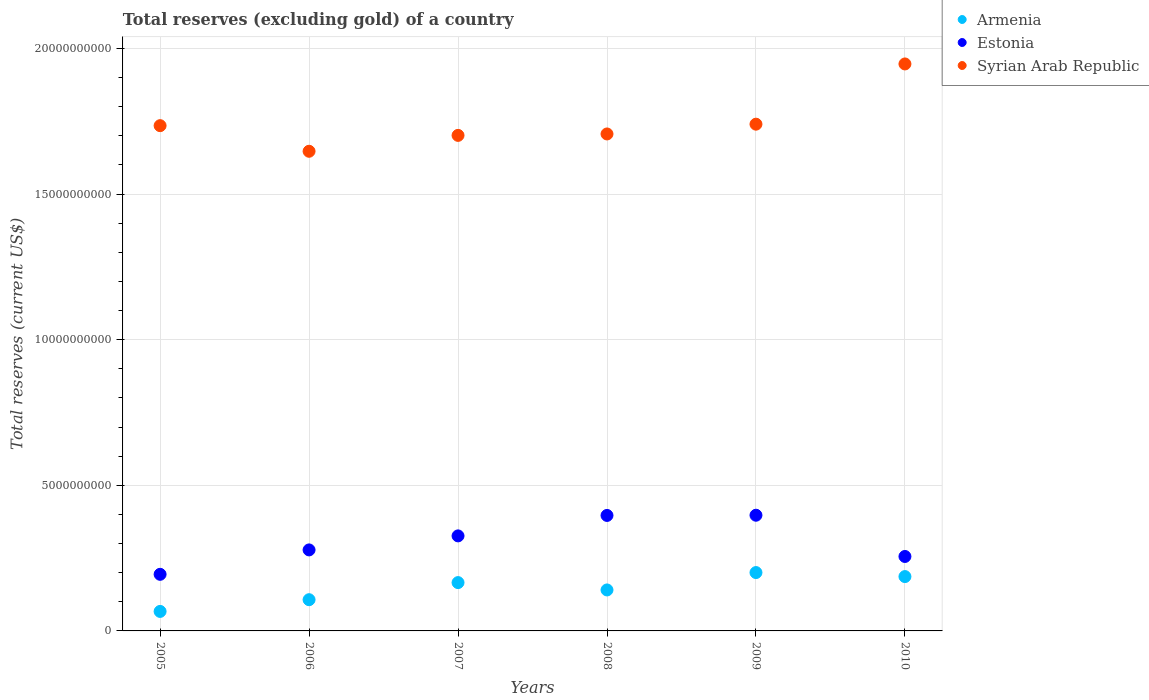How many different coloured dotlines are there?
Offer a very short reply. 3. Is the number of dotlines equal to the number of legend labels?
Offer a terse response. Yes. What is the total reserves (excluding gold) in Estonia in 2009?
Your answer should be compact. 3.97e+09. Across all years, what is the maximum total reserves (excluding gold) in Syrian Arab Republic?
Offer a terse response. 1.95e+1. Across all years, what is the minimum total reserves (excluding gold) in Syrian Arab Republic?
Offer a terse response. 1.65e+1. What is the total total reserves (excluding gold) in Estonia in the graph?
Make the answer very short. 1.85e+1. What is the difference between the total reserves (excluding gold) in Armenia in 2005 and that in 2006?
Ensure brevity in your answer.  -4.02e+08. What is the difference between the total reserves (excluding gold) in Estonia in 2005 and the total reserves (excluding gold) in Syrian Arab Republic in 2010?
Give a very brief answer. -1.75e+1. What is the average total reserves (excluding gold) in Syrian Arab Republic per year?
Make the answer very short. 1.75e+1. In the year 2007, what is the difference between the total reserves (excluding gold) in Armenia and total reserves (excluding gold) in Estonia?
Offer a very short reply. -1.60e+09. In how many years, is the total reserves (excluding gold) in Syrian Arab Republic greater than 5000000000 US$?
Keep it short and to the point. 6. What is the ratio of the total reserves (excluding gold) in Armenia in 2009 to that in 2010?
Offer a terse response. 1.07. Is the total reserves (excluding gold) in Syrian Arab Republic in 2005 less than that in 2010?
Provide a succinct answer. Yes. What is the difference between the highest and the second highest total reserves (excluding gold) in Estonia?
Give a very brief answer. 7.06e+06. What is the difference between the highest and the lowest total reserves (excluding gold) in Armenia?
Provide a succinct answer. 1.33e+09. In how many years, is the total reserves (excluding gold) in Estonia greater than the average total reserves (excluding gold) in Estonia taken over all years?
Provide a short and direct response. 3. Does the total reserves (excluding gold) in Syrian Arab Republic monotonically increase over the years?
Provide a short and direct response. No. Is the total reserves (excluding gold) in Syrian Arab Republic strictly greater than the total reserves (excluding gold) in Armenia over the years?
Provide a succinct answer. Yes. Is the total reserves (excluding gold) in Armenia strictly less than the total reserves (excluding gold) in Syrian Arab Republic over the years?
Keep it short and to the point. Yes. How many dotlines are there?
Give a very brief answer. 3. How many years are there in the graph?
Provide a succinct answer. 6. What is the difference between two consecutive major ticks on the Y-axis?
Give a very brief answer. 5.00e+09. Are the values on the major ticks of Y-axis written in scientific E-notation?
Make the answer very short. No. Does the graph contain grids?
Provide a succinct answer. Yes. How many legend labels are there?
Your answer should be compact. 3. How are the legend labels stacked?
Make the answer very short. Vertical. What is the title of the graph?
Make the answer very short. Total reserves (excluding gold) of a country. What is the label or title of the X-axis?
Provide a short and direct response. Years. What is the label or title of the Y-axis?
Give a very brief answer. Total reserves (current US$). What is the Total reserves (current US$) of Armenia in 2005?
Give a very brief answer. 6.69e+08. What is the Total reserves (current US$) of Estonia in 2005?
Make the answer very short. 1.94e+09. What is the Total reserves (current US$) of Syrian Arab Republic in 2005?
Keep it short and to the point. 1.73e+1. What is the Total reserves (current US$) in Armenia in 2006?
Keep it short and to the point. 1.07e+09. What is the Total reserves (current US$) of Estonia in 2006?
Provide a succinct answer. 2.78e+09. What is the Total reserves (current US$) in Syrian Arab Republic in 2006?
Your response must be concise. 1.65e+1. What is the Total reserves (current US$) of Armenia in 2007?
Provide a short and direct response. 1.66e+09. What is the Total reserves (current US$) of Estonia in 2007?
Your response must be concise. 3.26e+09. What is the Total reserves (current US$) of Syrian Arab Republic in 2007?
Keep it short and to the point. 1.70e+1. What is the Total reserves (current US$) in Armenia in 2008?
Keep it short and to the point. 1.41e+09. What is the Total reserves (current US$) in Estonia in 2008?
Your answer should be very brief. 3.96e+09. What is the Total reserves (current US$) in Syrian Arab Republic in 2008?
Give a very brief answer. 1.71e+1. What is the Total reserves (current US$) of Armenia in 2009?
Ensure brevity in your answer.  2.00e+09. What is the Total reserves (current US$) of Estonia in 2009?
Give a very brief answer. 3.97e+09. What is the Total reserves (current US$) of Syrian Arab Republic in 2009?
Make the answer very short. 1.74e+1. What is the Total reserves (current US$) in Armenia in 2010?
Keep it short and to the point. 1.87e+09. What is the Total reserves (current US$) in Estonia in 2010?
Your answer should be compact. 2.56e+09. What is the Total reserves (current US$) of Syrian Arab Republic in 2010?
Make the answer very short. 1.95e+1. Across all years, what is the maximum Total reserves (current US$) of Armenia?
Your answer should be very brief. 2.00e+09. Across all years, what is the maximum Total reserves (current US$) in Estonia?
Keep it short and to the point. 3.97e+09. Across all years, what is the maximum Total reserves (current US$) in Syrian Arab Republic?
Provide a succinct answer. 1.95e+1. Across all years, what is the minimum Total reserves (current US$) in Armenia?
Give a very brief answer. 6.69e+08. Across all years, what is the minimum Total reserves (current US$) in Estonia?
Your response must be concise. 1.94e+09. Across all years, what is the minimum Total reserves (current US$) of Syrian Arab Republic?
Your response must be concise. 1.65e+1. What is the total Total reserves (current US$) of Armenia in the graph?
Ensure brevity in your answer.  8.68e+09. What is the total Total reserves (current US$) in Estonia in the graph?
Ensure brevity in your answer.  1.85e+1. What is the total Total reserves (current US$) of Syrian Arab Republic in the graph?
Offer a terse response. 1.05e+11. What is the difference between the Total reserves (current US$) in Armenia in 2005 and that in 2006?
Give a very brief answer. -4.02e+08. What is the difference between the Total reserves (current US$) of Estonia in 2005 and that in 2006?
Keep it short and to the point. -8.38e+08. What is the difference between the Total reserves (current US$) of Syrian Arab Republic in 2005 and that in 2006?
Make the answer very short. 8.79e+08. What is the difference between the Total reserves (current US$) in Armenia in 2005 and that in 2007?
Your answer should be compact. -9.90e+08. What is the difference between the Total reserves (current US$) in Estonia in 2005 and that in 2007?
Offer a terse response. -1.32e+09. What is the difference between the Total reserves (current US$) in Syrian Arab Republic in 2005 and that in 2007?
Offer a terse response. 3.34e+08. What is the difference between the Total reserves (current US$) in Armenia in 2005 and that in 2008?
Your answer should be very brief. -7.37e+08. What is the difference between the Total reserves (current US$) of Estonia in 2005 and that in 2008?
Your response must be concise. -2.02e+09. What is the difference between the Total reserves (current US$) of Syrian Arab Republic in 2005 and that in 2008?
Offer a terse response. 2.85e+08. What is the difference between the Total reserves (current US$) of Armenia in 2005 and that in 2009?
Give a very brief answer. -1.33e+09. What is the difference between the Total reserves (current US$) in Estonia in 2005 and that in 2009?
Your response must be concise. -2.03e+09. What is the difference between the Total reserves (current US$) in Syrian Arab Republic in 2005 and that in 2009?
Offer a very short reply. -5.09e+07. What is the difference between the Total reserves (current US$) in Armenia in 2005 and that in 2010?
Provide a short and direct response. -1.20e+09. What is the difference between the Total reserves (current US$) of Estonia in 2005 and that in 2010?
Your answer should be very brief. -6.13e+08. What is the difference between the Total reserves (current US$) in Syrian Arab Republic in 2005 and that in 2010?
Provide a succinct answer. -2.12e+09. What is the difference between the Total reserves (current US$) in Armenia in 2006 and that in 2007?
Offer a very short reply. -5.87e+08. What is the difference between the Total reserves (current US$) in Estonia in 2006 and that in 2007?
Your response must be concise. -4.81e+08. What is the difference between the Total reserves (current US$) in Syrian Arab Republic in 2006 and that in 2007?
Offer a terse response. -5.46e+08. What is the difference between the Total reserves (current US$) of Armenia in 2006 and that in 2008?
Your response must be concise. -3.35e+08. What is the difference between the Total reserves (current US$) in Estonia in 2006 and that in 2008?
Give a very brief answer. -1.18e+09. What is the difference between the Total reserves (current US$) of Syrian Arab Republic in 2006 and that in 2008?
Offer a very short reply. -5.95e+08. What is the difference between the Total reserves (current US$) in Armenia in 2006 and that in 2009?
Provide a succinct answer. -9.32e+08. What is the difference between the Total reserves (current US$) in Estonia in 2006 and that in 2009?
Your answer should be very brief. -1.19e+09. What is the difference between the Total reserves (current US$) of Syrian Arab Republic in 2006 and that in 2009?
Provide a short and direct response. -9.30e+08. What is the difference between the Total reserves (current US$) of Armenia in 2006 and that in 2010?
Provide a short and direct response. -7.94e+08. What is the difference between the Total reserves (current US$) in Estonia in 2006 and that in 2010?
Provide a short and direct response. 2.25e+08. What is the difference between the Total reserves (current US$) of Syrian Arab Republic in 2006 and that in 2010?
Make the answer very short. -3.00e+09. What is the difference between the Total reserves (current US$) of Armenia in 2007 and that in 2008?
Provide a short and direct response. 2.52e+08. What is the difference between the Total reserves (current US$) in Estonia in 2007 and that in 2008?
Make the answer very short. -7.02e+08. What is the difference between the Total reserves (current US$) of Syrian Arab Republic in 2007 and that in 2008?
Provide a short and direct response. -4.89e+07. What is the difference between the Total reserves (current US$) of Armenia in 2007 and that in 2009?
Your answer should be very brief. -3.45e+08. What is the difference between the Total reserves (current US$) of Estonia in 2007 and that in 2009?
Provide a short and direct response. -7.09e+08. What is the difference between the Total reserves (current US$) of Syrian Arab Republic in 2007 and that in 2009?
Offer a terse response. -3.85e+08. What is the difference between the Total reserves (current US$) of Armenia in 2007 and that in 2010?
Ensure brevity in your answer.  -2.07e+08. What is the difference between the Total reserves (current US$) of Estonia in 2007 and that in 2010?
Keep it short and to the point. 7.07e+08. What is the difference between the Total reserves (current US$) of Syrian Arab Republic in 2007 and that in 2010?
Offer a very short reply. -2.45e+09. What is the difference between the Total reserves (current US$) of Armenia in 2008 and that in 2009?
Offer a very short reply. -5.97e+08. What is the difference between the Total reserves (current US$) in Estonia in 2008 and that in 2009?
Your answer should be compact. -7.06e+06. What is the difference between the Total reserves (current US$) of Syrian Arab Republic in 2008 and that in 2009?
Keep it short and to the point. -3.36e+08. What is the difference between the Total reserves (current US$) of Armenia in 2008 and that in 2010?
Your response must be concise. -4.59e+08. What is the difference between the Total reserves (current US$) of Estonia in 2008 and that in 2010?
Offer a terse response. 1.41e+09. What is the difference between the Total reserves (current US$) of Syrian Arab Republic in 2008 and that in 2010?
Keep it short and to the point. -2.40e+09. What is the difference between the Total reserves (current US$) of Armenia in 2009 and that in 2010?
Give a very brief answer. 1.38e+08. What is the difference between the Total reserves (current US$) of Estonia in 2009 and that in 2010?
Ensure brevity in your answer.  1.42e+09. What is the difference between the Total reserves (current US$) in Syrian Arab Republic in 2009 and that in 2010?
Make the answer very short. -2.07e+09. What is the difference between the Total reserves (current US$) of Armenia in 2005 and the Total reserves (current US$) of Estonia in 2006?
Offer a very short reply. -2.11e+09. What is the difference between the Total reserves (current US$) of Armenia in 2005 and the Total reserves (current US$) of Syrian Arab Republic in 2006?
Your answer should be compact. -1.58e+1. What is the difference between the Total reserves (current US$) in Estonia in 2005 and the Total reserves (current US$) in Syrian Arab Republic in 2006?
Your response must be concise. -1.45e+1. What is the difference between the Total reserves (current US$) of Armenia in 2005 and the Total reserves (current US$) of Estonia in 2007?
Give a very brief answer. -2.59e+09. What is the difference between the Total reserves (current US$) in Armenia in 2005 and the Total reserves (current US$) in Syrian Arab Republic in 2007?
Provide a short and direct response. -1.63e+1. What is the difference between the Total reserves (current US$) in Estonia in 2005 and the Total reserves (current US$) in Syrian Arab Republic in 2007?
Your response must be concise. -1.51e+1. What is the difference between the Total reserves (current US$) in Armenia in 2005 and the Total reserves (current US$) in Estonia in 2008?
Keep it short and to the point. -3.30e+09. What is the difference between the Total reserves (current US$) in Armenia in 2005 and the Total reserves (current US$) in Syrian Arab Republic in 2008?
Provide a short and direct response. -1.64e+1. What is the difference between the Total reserves (current US$) of Estonia in 2005 and the Total reserves (current US$) of Syrian Arab Republic in 2008?
Your answer should be very brief. -1.51e+1. What is the difference between the Total reserves (current US$) in Armenia in 2005 and the Total reserves (current US$) in Estonia in 2009?
Offer a very short reply. -3.30e+09. What is the difference between the Total reserves (current US$) in Armenia in 2005 and the Total reserves (current US$) in Syrian Arab Republic in 2009?
Your answer should be compact. -1.67e+1. What is the difference between the Total reserves (current US$) of Estonia in 2005 and the Total reserves (current US$) of Syrian Arab Republic in 2009?
Make the answer very short. -1.55e+1. What is the difference between the Total reserves (current US$) of Armenia in 2005 and the Total reserves (current US$) of Estonia in 2010?
Provide a short and direct response. -1.89e+09. What is the difference between the Total reserves (current US$) in Armenia in 2005 and the Total reserves (current US$) in Syrian Arab Republic in 2010?
Your response must be concise. -1.88e+1. What is the difference between the Total reserves (current US$) in Estonia in 2005 and the Total reserves (current US$) in Syrian Arab Republic in 2010?
Offer a terse response. -1.75e+1. What is the difference between the Total reserves (current US$) in Armenia in 2006 and the Total reserves (current US$) in Estonia in 2007?
Your response must be concise. -2.19e+09. What is the difference between the Total reserves (current US$) in Armenia in 2006 and the Total reserves (current US$) in Syrian Arab Republic in 2007?
Offer a very short reply. -1.59e+1. What is the difference between the Total reserves (current US$) in Estonia in 2006 and the Total reserves (current US$) in Syrian Arab Republic in 2007?
Provide a short and direct response. -1.42e+1. What is the difference between the Total reserves (current US$) in Armenia in 2006 and the Total reserves (current US$) in Estonia in 2008?
Make the answer very short. -2.89e+09. What is the difference between the Total reserves (current US$) in Armenia in 2006 and the Total reserves (current US$) in Syrian Arab Republic in 2008?
Your response must be concise. -1.60e+1. What is the difference between the Total reserves (current US$) in Estonia in 2006 and the Total reserves (current US$) in Syrian Arab Republic in 2008?
Give a very brief answer. -1.43e+1. What is the difference between the Total reserves (current US$) of Armenia in 2006 and the Total reserves (current US$) of Estonia in 2009?
Ensure brevity in your answer.  -2.90e+09. What is the difference between the Total reserves (current US$) in Armenia in 2006 and the Total reserves (current US$) in Syrian Arab Republic in 2009?
Your answer should be compact. -1.63e+1. What is the difference between the Total reserves (current US$) of Estonia in 2006 and the Total reserves (current US$) of Syrian Arab Republic in 2009?
Your answer should be very brief. -1.46e+1. What is the difference between the Total reserves (current US$) of Armenia in 2006 and the Total reserves (current US$) of Estonia in 2010?
Your answer should be compact. -1.48e+09. What is the difference between the Total reserves (current US$) of Armenia in 2006 and the Total reserves (current US$) of Syrian Arab Republic in 2010?
Keep it short and to the point. -1.84e+1. What is the difference between the Total reserves (current US$) of Estonia in 2006 and the Total reserves (current US$) of Syrian Arab Republic in 2010?
Your answer should be compact. -1.67e+1. What is the difference between the Total reserves (current US$) of Armenia in 2007 and the Total reserves (current US$) of Estonia in 2008?
Give a very brief answer. -2.31e+09. What is the difference between the Total reserves (current US$) in Armenia in 2007 and the Total reserves (current US$) in Syrian Arab Republic in 2008?
Make the answer very short. -1.54e+1. What is the difference between the Total reserves (current US$) of Estonia in 2007 and the Total reserves (current US$) of Syrian Arab Republic in 2008?
Provide a succinct answer. -1.38e+1. What is the difference between the Total reserves (current US$) in Armenia in 2007 and the Total reserves (current US$) in Estonia in 2009?
Your answer should be very brief. -2.31e+09. What is the difference between the Total reserves (current US$) of Armenia in 2007 and the Total reserves (current US$) of Syrian Arab Republic in 2009?
Offer a very short reply. -1.57e+1. What is the difference between the Total reserves (current US$) of Estonia in 2007 and the Total reserves (current US$) of Syrian Arab Republic in 2009?
Ensure brevity in your answer.  -1.41e+1. What is the difference between the Total reserves (current US$) of Armenia in 2007 and the Total reserves (current US$) of Estonia in 2010?
Keep it short and to the point. -8.97e+08. What is the difference between the Total reserves (current US$) of Armenia in 2007 and the Total reserves (current US$) of Syrian Arab Republic in 2010?
Your answer should be very brief. -1.78e+1. What is the difference between the Total reserves (current US$) in Estonia in 2007 and the Total reserves (current US$) in Syrian Arab Republic in 2010?
Your answer should be very brief. -1.62e+1. What is the difference between the Total reserves (current US$) in Armenia in 2008 and the Total reserves (current US$) in Estonia in 2009?
Ensure brevity in your answer.  -2.57e+09. What is the difference between the Total reserves (current US$) of Armenia in 2008 and the Total reserves (current US$) of Syrian Arab Republic in 2009?
Offer a terse response. -1.60e+1. What is the difference between the Total reserves (current US$) in Estonia in 2008 and the Total reserves (current US$) in Syrian Arab Republic in 2009?
Provide a succinct answer. -1.34e+1. What is the difference between the Total reserves (current US$) in Armenia in 2008 and the Total reserves (current US$) in Estonia in 2010?
Your answer should be very brief. -1.15e+09. What is the difference between the Total reserves (current US$) in Armenia in 2008 and the Total reserves (current US$) in Syrian Arab Republic in 2010?
Make the answer very short. -1.81e+1. What is the difference between the Total reserves (current US$) in Estonia in 2008 and the Total reserves (current US$) in Syrian Arab Republic in 2010?
Offer a terse response. -1.55e+1. What is the difference between the Total reserves (current US$) of Armenia in 2009 and the Total reserves (current US$) of Estonia in 2010?
Your answer should be very brief. -5.52e+08. What is the difference between the Total reserves (current US$) in Armenia in 2009 and the Total reserves (current US$) in Syrian Arab Republic in 2010?
Your answer should be compact. -1.75e+1. What is the difference between the Total reserves (current US$) in Estonia in 2009 and the Total reserves (current US$) in Syrian Arab Republic in 2010?
Offer a terse response. -1.55e+1. What is the average Total reserves (current US$) in Armenia per year?
Offer a terse response. 1.45e+09. What is the average Total reserves (current US$) in Estonia per year?
Provide a short and direct response. 3.08e+09. What is the average Total reserves (current US$) in Syrian Arab Republic per year?
Your response must be concise. 1.75e+1. In the year 2005, what is the difference between the Total reserves (current US$) in Armenia and Total reserves (current US$) in Estonia?
Offer a very short reply. -1.27e+09. In the year 2005, what is the difference between the Total reserves (current US$) of Armenia and Total reserves (current US$) of Syrian Arab Republic?
Your answer should be compact. -1.67e+1. In the year 2005, what is the difference between the Total reserves (current US$) of Estonia and Total reserves (current US$) of Syrian Arab Republic?
Give a very brief answer. -1.54e+1. In the year 2006, what is the difference between the Total reserves (current US$) in Armenia and Total reserves (current US$) in Estonia?
Your answer should be very brief. -1.71e+09. In the year 2006, what is the difference between the Total reserves (current US$) of Armenia and Total reserves (current US$) of Syrian Arab Republic?
Give a very brief answer. -1.54e+1. In the year 2006, what is the difference between the Total reserves (current US$) of Estonia and Total reserves (current US$) of Syrian Arab Republic?
Provide a succinct answer. -1.37e+1. In the year 2007, what is the difference between the Total reserves (current US$) of Armenia and Total reserves (current US$) of Estonia?
Provide a short and direct response. -1.60e+09. In the year 2007, what is the difference between the Total reserves (current US$) in Armenia and Total reserves (current US$) in Syrian Arab Republic?
Give a very brief answer. -1.54e+1. In the year 2007, what is the difference between the Total reserves (current US$) of Estonia and Total reserves (current US$) of Syrian Arab Republic?
Provide a succinct answer. -1.38e+1. In the year 2008, what is the difference between the Total reserves (current US$) of Armenia and Total reserves (current US$) of Estonia?
Give a very brief answer. -2.56e+09. In the year 2008, what is the difference between the Total reserves (current US$) of Armenia and Total reserves (current US$) of Syrian Arab Republic?
Offer a very short reply. -1.57e+1. In the year 2008, what is the difference between the Total reserves (current US$) in Estonia and Total reserves (current US$) in Syrian Arab Republic?
Your answer should be compact. -1.31e+1. In the year 2009, what is the difference between the Total reserves (current US$) of Armenia and Total reserves (current US$) of Estonia?
Provide a short and direct response. -1.97e+09. In the year 2009, what is the difference between the Total reserves (current US$) of Armenia and Total reserves (current US$) of Syrian Arab Republic?
Keep it short and to the point. -1.54e+1. In the year 2009, what is the difference between the Total reserves (current US$) in Estonia and Total reserves (current US$) in Syrian Arab Republic?
Offer a very short reply. -1.34e+1. In the year 2010, what is the difference between the Total reserves (current US$) in Armenia and Total reserves (current US$) in Estonia?
Give a very brief answer. -6.90e+08. In the year 2010, what is the difference between the Total reserves (current US$) of Armenia and Total reserves (current US$) of Syrian Arab Republic?
Provide a succinct answer. -1.76e+1. In the year 2010, what is the difference between the Total reserves (current US$) of Estonia and Total reserves (current US$) of Syrian Arab Republic?
Make the answer very short. -1.69e+1. What is the ratio of the Total reserves (current US$) in Armenia in 2005 to that in 2006?
Your answer should be very brief. 0.62. What is the ratio of the Total reserves (current US$) in Estonia in 2005 to that in 2006?
Provide a succinct answer. 0.7. What is the ratio of the Total reserves (current US$) of Syrian Arab Republic in 2005 to that in 2006?
Offer a terse response. 1.05. What is the ratio of the Total reserves (current US$) of Armenia in 2005 to that in 2007?
Offer a terse response. 0.4. What is the ratio of the Total reserves (current US$) of Estonia in 2005 to that in 2007?
Provide a succinct answer. 0.6. What is the ratio of the Total reserves (current US$) of Syrian Arab Republic in 2005 to that in 2007?
Your answer should be very brief. 1.02. What is the ratio of the Total reserves (current US$) of Armenia in 2005 to that in 2008?
Offer a terse response. 0.48. What is the ratio of the Total reserves (current US$) in Estonia in 2005 to that in 2008?
Your answer should be very brief. 0.49. What is the ratio of the Total reserves (current US$) in Syrian Arab Republic in 2005 to that in 2008?
Provide a succinct answer. 1.02. What is the ratio of the Total reserves (current US$) in Armenia in 2005 to that in 2009?
Make the answer very short. 0.33. What is the ratio of the Total reserves (current US$) in Estonia in 2005 to that in 2009?
Your response must be concise. 0.49. What is the ratio of the Total reserves (current US$) of Armenia in 2005 to that in 2010?
Provide a succinct answer. 0.36. What is the ratio of the Total reserves (current US$) of Estonia in 2005 to that in 2010?
Make the answer very short. 0.76. What is the ratio of the Total reserves (current US$) in Syrian Arab Republic in 2005 to that in 2010?
Provide a short and direct response. 0.89. What is the ratio of the Total reserves (current US$) of Armenia in 2006 to that in 2007?
Give a very brief answer. 0.65. What is the ratio of the Total reserves (current US$) of Estonia in 2006 to that in 2007?
Your answer should be compact. 0.85. What is the ratio of the Total reserves (current US$) in Syrian Arab Republic in 2006 to that in 2007?
Your answer should be very brief. 0.97. What is the ratio of the Total reserves (current US$) of Armenia in 2006 to that in 2008?
Your response must be concise. 0.76. What is the ratio of the Total reserves (current US$) in Estonia in 2006 to that in 2008?
Your answer should be very brief. 0.7. What is the ratio of the Total reserves (current US$) of Syrian Arab Republic in 2006 to that in 2008?
Offer a terse response. 0.97. What is the ratio of the Total reserves (current US$) in Armenia in 2006 to that in 2009?
Your response must be concise. 0.54. What is the ratio of the Total reserves (current US$) in Estonia in 2006 to that in 2009?
Keep it short and to the point. 0.7. What is the ratio of the Total reserves (current US$) in Syrian Arab Republic in 2006 to that in 2009?
Keep it short and to the point. 0.95. What is the ratio of the Total reserves (current US$) in Armenia in 2006 to that in 2010?
Provide a short and direct response. 0.57. What is the ratio of the Total reserves (current US$) in Estonia in 2006 to that in 2010?
Ensure brevity in your answer.  1.09. What is the ratio of the Total reserves (current US$) in Syrian Arab Republic in 2006 to that in 2010?
Keep it short and to the point. 0.85. What is the ratio of the Total reserves (current US$) of Armenia in 2007 to that in 2008?
Offer a terse response. 1.18. What is the ratio of the Total reserves (current US$) in Estonia in 2007 to that in 2008?
Your response must be concise. 0.82. What is the ratio of the Total reserves (current US$) of Armenia in 2007 to that in 2009?
Your response must be concise. 0.83. What is the ratio of the Total reserves (current US$) in Estonia in 2007 to that in 2009?
Offer a very short reply. 0.82. What is the ratio of the Total reserves (current US$) of Syrian Arab Republic in 2007 to that in 2009?
Offer a very short reply. 0.98. What is the ratio of the Total reserves (current US$) of Armenia in 2007 to that in 2010?
Your answer should be very brief. 0.89. What is the ratio of the Total reserves (current US$) in Estonia in 2007 to that in 2010?
Your answer should be very brief. 1.28. What is the ratio of the Total reserves (current US$) in Syrian Arab Republic in 2007 to that in 2010?
Offer a terse response. 0.87. What is the ratio of the Total reserves (current US$) of Armenia in 2008 to that in 2009?
Provide a succinct answer. 0.7. What is the ratio of the Total reserves (current US$) in Estonia in 2008 to that in 2009?
Offer a very short reply. 1. What is the ratio of the Total reserves (current US$) of Syrian Arab Republic in 2008 to that in 2009?
Keep it short and to the point. 0.98. What is the ratio of the Total reserves (current US$) in Armenia in 2008 to that in 2010?
Keep it short and to the point. 0.75. What is the ratio of the Total reserves (current US$) of Estonia in 2008 to that in 2010?
Offer a terse response. 1.55. What is the ratio of the Total reserves (current US$) in Syrian Arab Republic in 2008 to that in 2010?
Make the answer very short. 0.88. What is the ratio of the Total reserves (current US$) in Armenia in 2009 to that in 2010?
Give a very brief answer. 1.07. What is the ratio of the Total reserves (current US$) of Estonia in 2009 to that in 2010?
Provide a succinct answer. 1.55. What is the ratio of the Total reserves (current US$) of Syrian Arab Republic in 2009 to that in 2010?
Your answer should be very brief. 0.89. What is the difference between the highest and the second highest Total reserves (current US$) of Armenia?
Give a very brief answer. 1.38e+08. What is the difference between the highest and the second highest Total reserves (current US$) of Estonia?
Your answer should be compact. 7.06e+06. What is the difference between the highest and the second highest Total reserves (current US$) of Syrian Arab Republic?
Your answer should be very brief. 2.07e+09. What is the difference between the highest and the lowest Total reserves (current US$) in Armenia?
Your answer should be very brief. 1.33e+09. What is the difference between the highest and the lowest Total reserves (current US$) of Estonia?
Give a very brief answer. 2.03e+09. What is the difference between the highest and the lowest Total reserves (current US$) of Syrian Arab Republic?
Make the answer very short. 3.00e+09. 